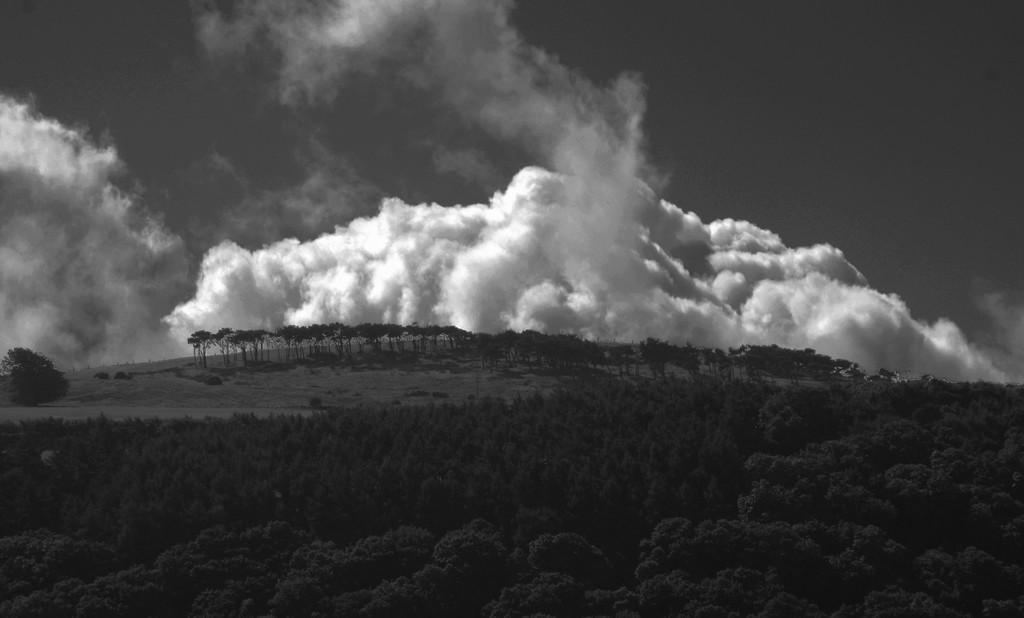What is located in the middle of the image? There are trees in the middle of the image. What is visible at the top of the image? The sky is visible at the top of the image. What color scheme is used in the image? The image is in black and white color. How many leaves can be seen falling from the trees in the image? There are no leaves falling from the trees in the image, as it is in black and white color and does not depict any movement. What type of leaf is being crushed underfoot in the image? There is no leaf being crushed underfoot in the image, as it is in black and white color and does not depict any movement or objects on the ground. 